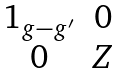<formula> <loc_0><loc_0><loc_500><loc_500>\begin{matrix} 1 _ { g - g ^ { \prime } } & 0 \\ 0 & Z \\ \end{matrix}</formula> 